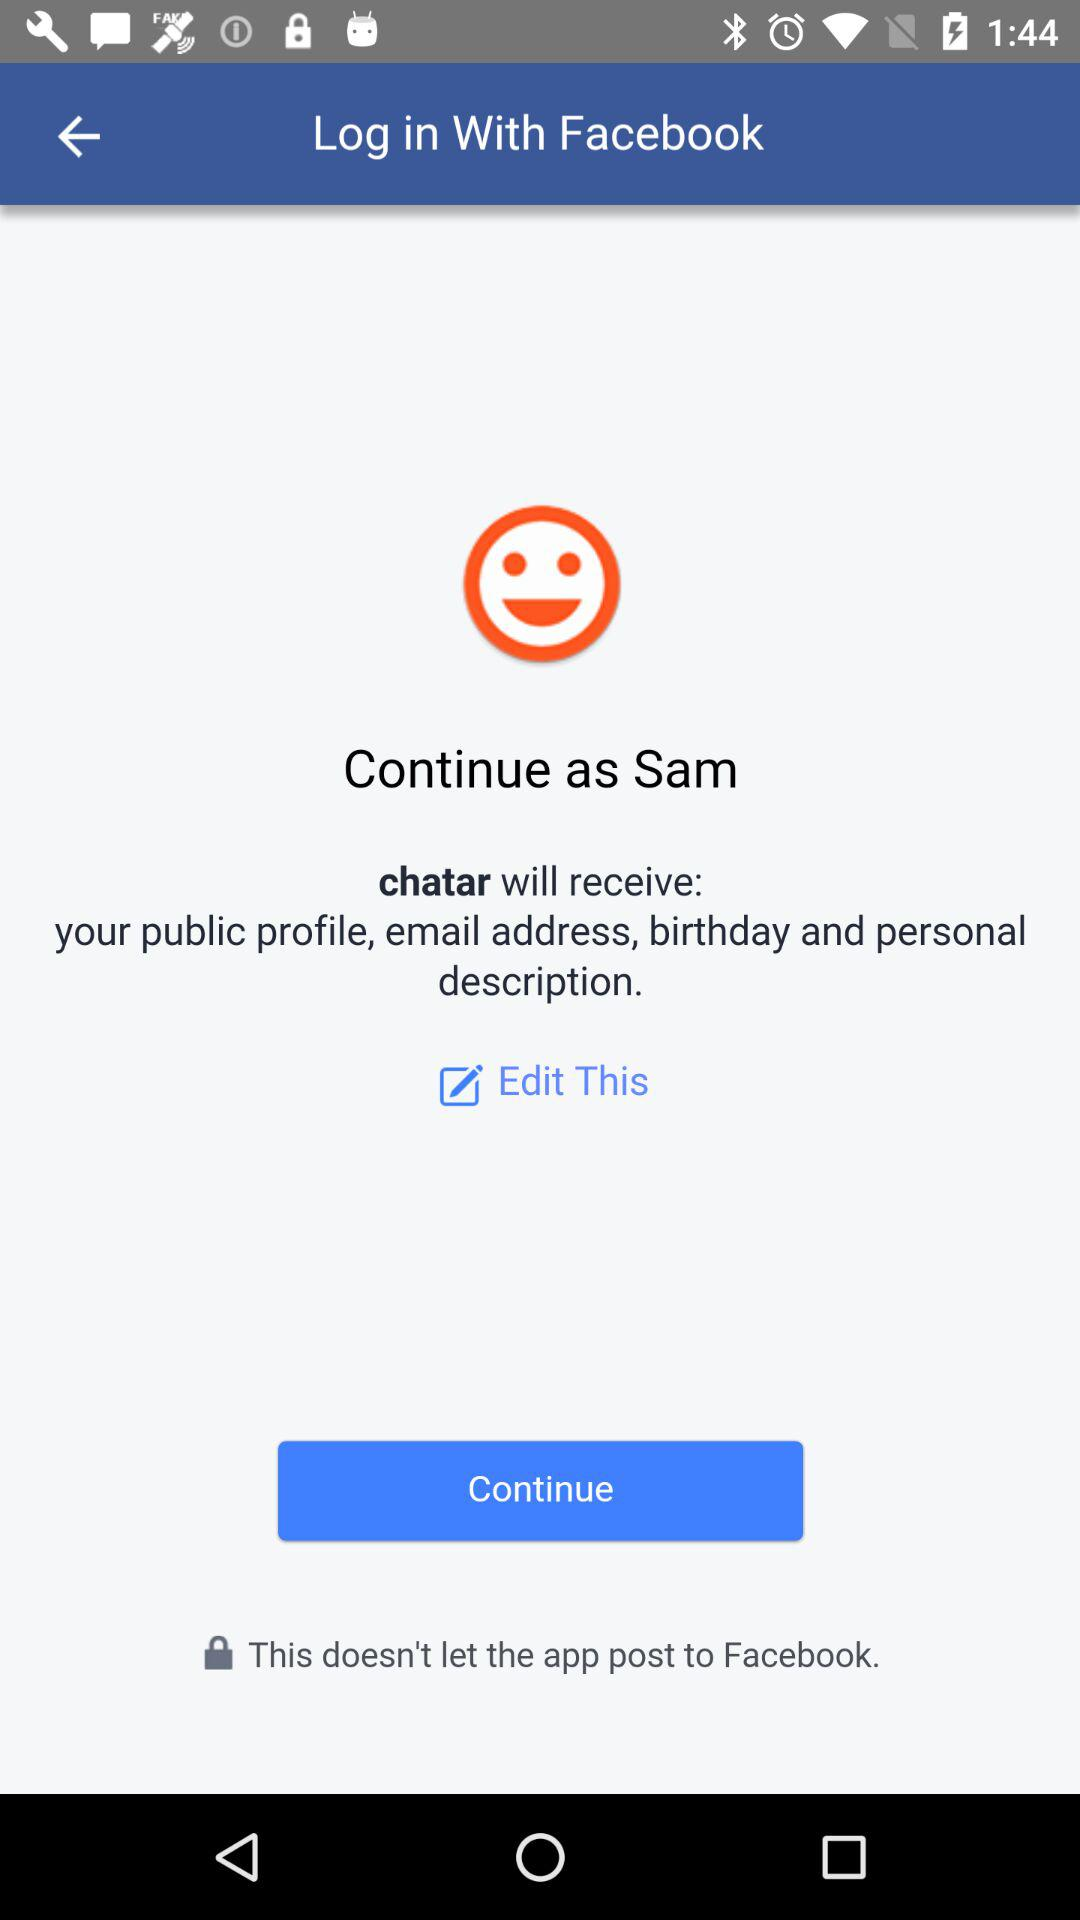What application is asking for permission? The application that is asking for permission is "chatar". 